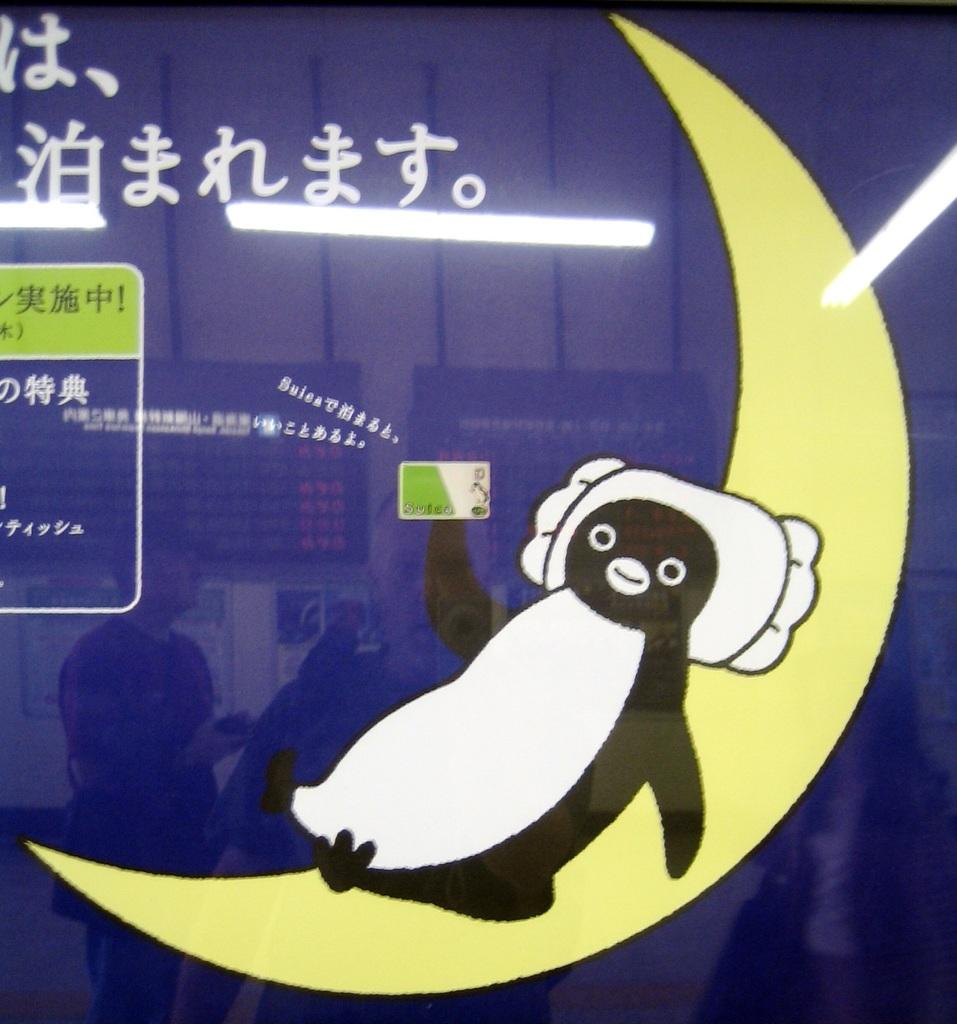What type of animal is depicted in the image? There is a picture of an anime penguin in the image. Where is the penguin located in the image? The penguin is laying on the moon. What else can be seen in the image besides the penguin? There is text above the picture. What type of amusement can be seen in the image? There is no amusement depicted in the image; it features a penguin laying on the moon. What achievement has the penguin accomplished in the image? There is no indication of any achievement in the image; it simply shows a penguin laying on the moon. 